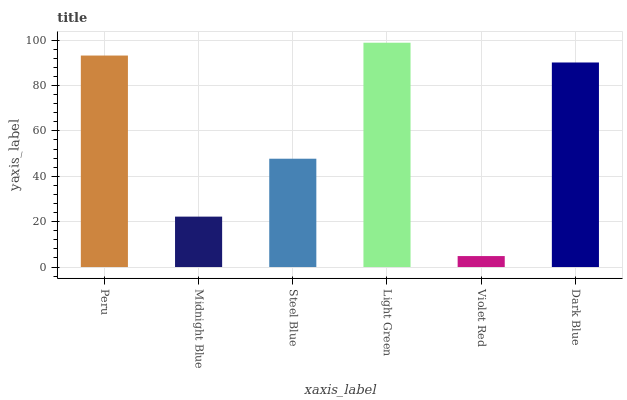Is Violet Red the minimum?
Answer yes or no. Yes. Is Light Green the maximum?
Answer yes or no. Yes. Is Midnight Blue the minimum?
Answer yes or no. No. Is Midnight Blue the maximum?
Answer yes or no. No. Is Peru greater than Midnight Blue?
Answer yes or no. Yes. Is Midnight Blue less than Peru?
Answer yes or no. Yes. Is Midnight Blue greater than Peru?
Answer yes or no. No. Is Peru less than Midnight Blue?
Answer yes or no. No. Is Dark Blue the high median?
Answer yes or no. Yes. Is Steel Blue the low median?
Answer yes or no. Yes. Is Midnight Blue the high median?
Answer yes or no. No. Is Violet Red the low median?
Answer yes or no. No. 